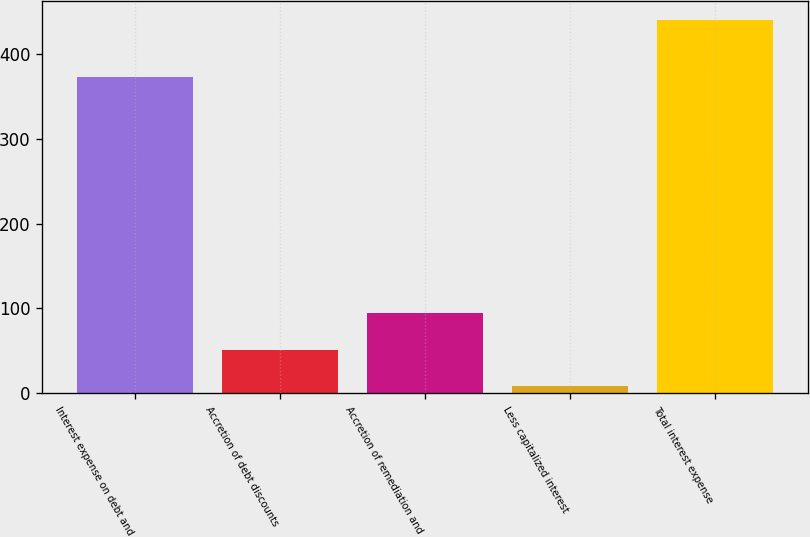Convert chart to OTSL. <chart><loc_0><loc_0><loc_500><loc_500><bar_chart><fcel>Interest expense on debt and<fcel>Accretion of debt discounts<fcel>Accretion of remediation and<fcel>Less capitalized interest<fcel>Total interest expense<nl><fcel>372.9<fcel>51.31<fcel>94.52<fcel>8.1<fcel>440.2<nl></chart> 